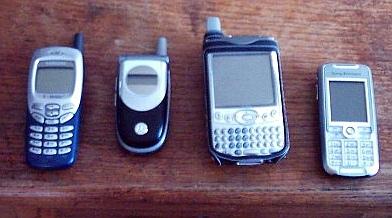Are these old mobile phones?
Keep it brief. Yes. How many are iPhones?
Keep it brief. 0. Is the oldest phone all the way on the left?
Give a very brief answer. Yes. Are any of these phones currently popular?
Be succinct. No. Are these cellular phone dated?
Be succinct. Yes. What kind of devices are these?
Write a very short answer. Cell phones. 